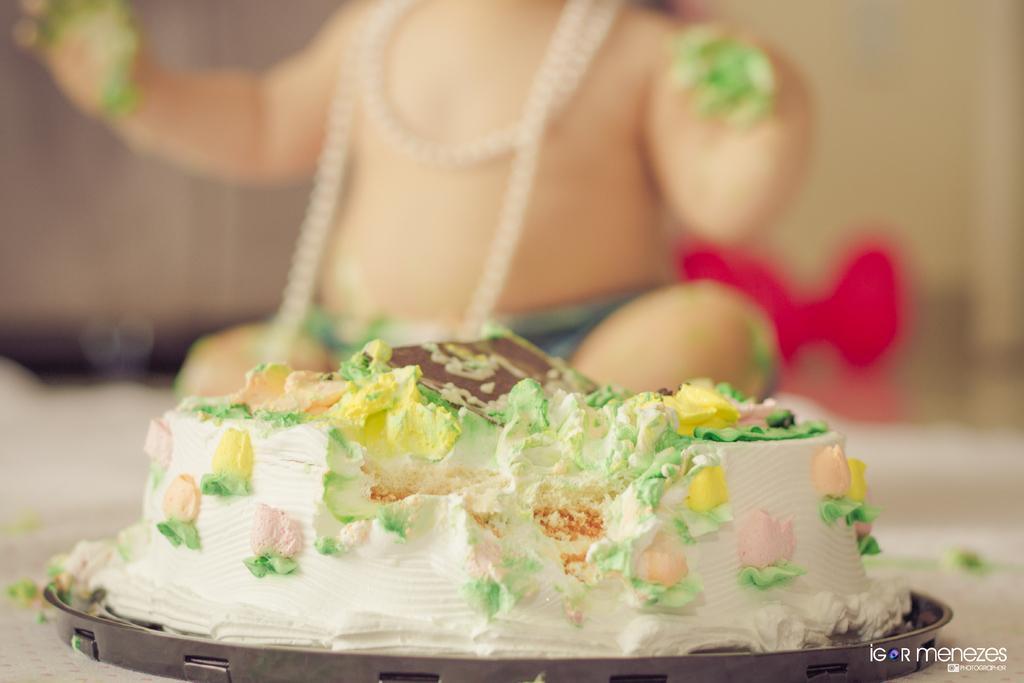Could you give a brief overview of what you see in this image? In the center of the image there is a cake. In the background of the image there is a child. 